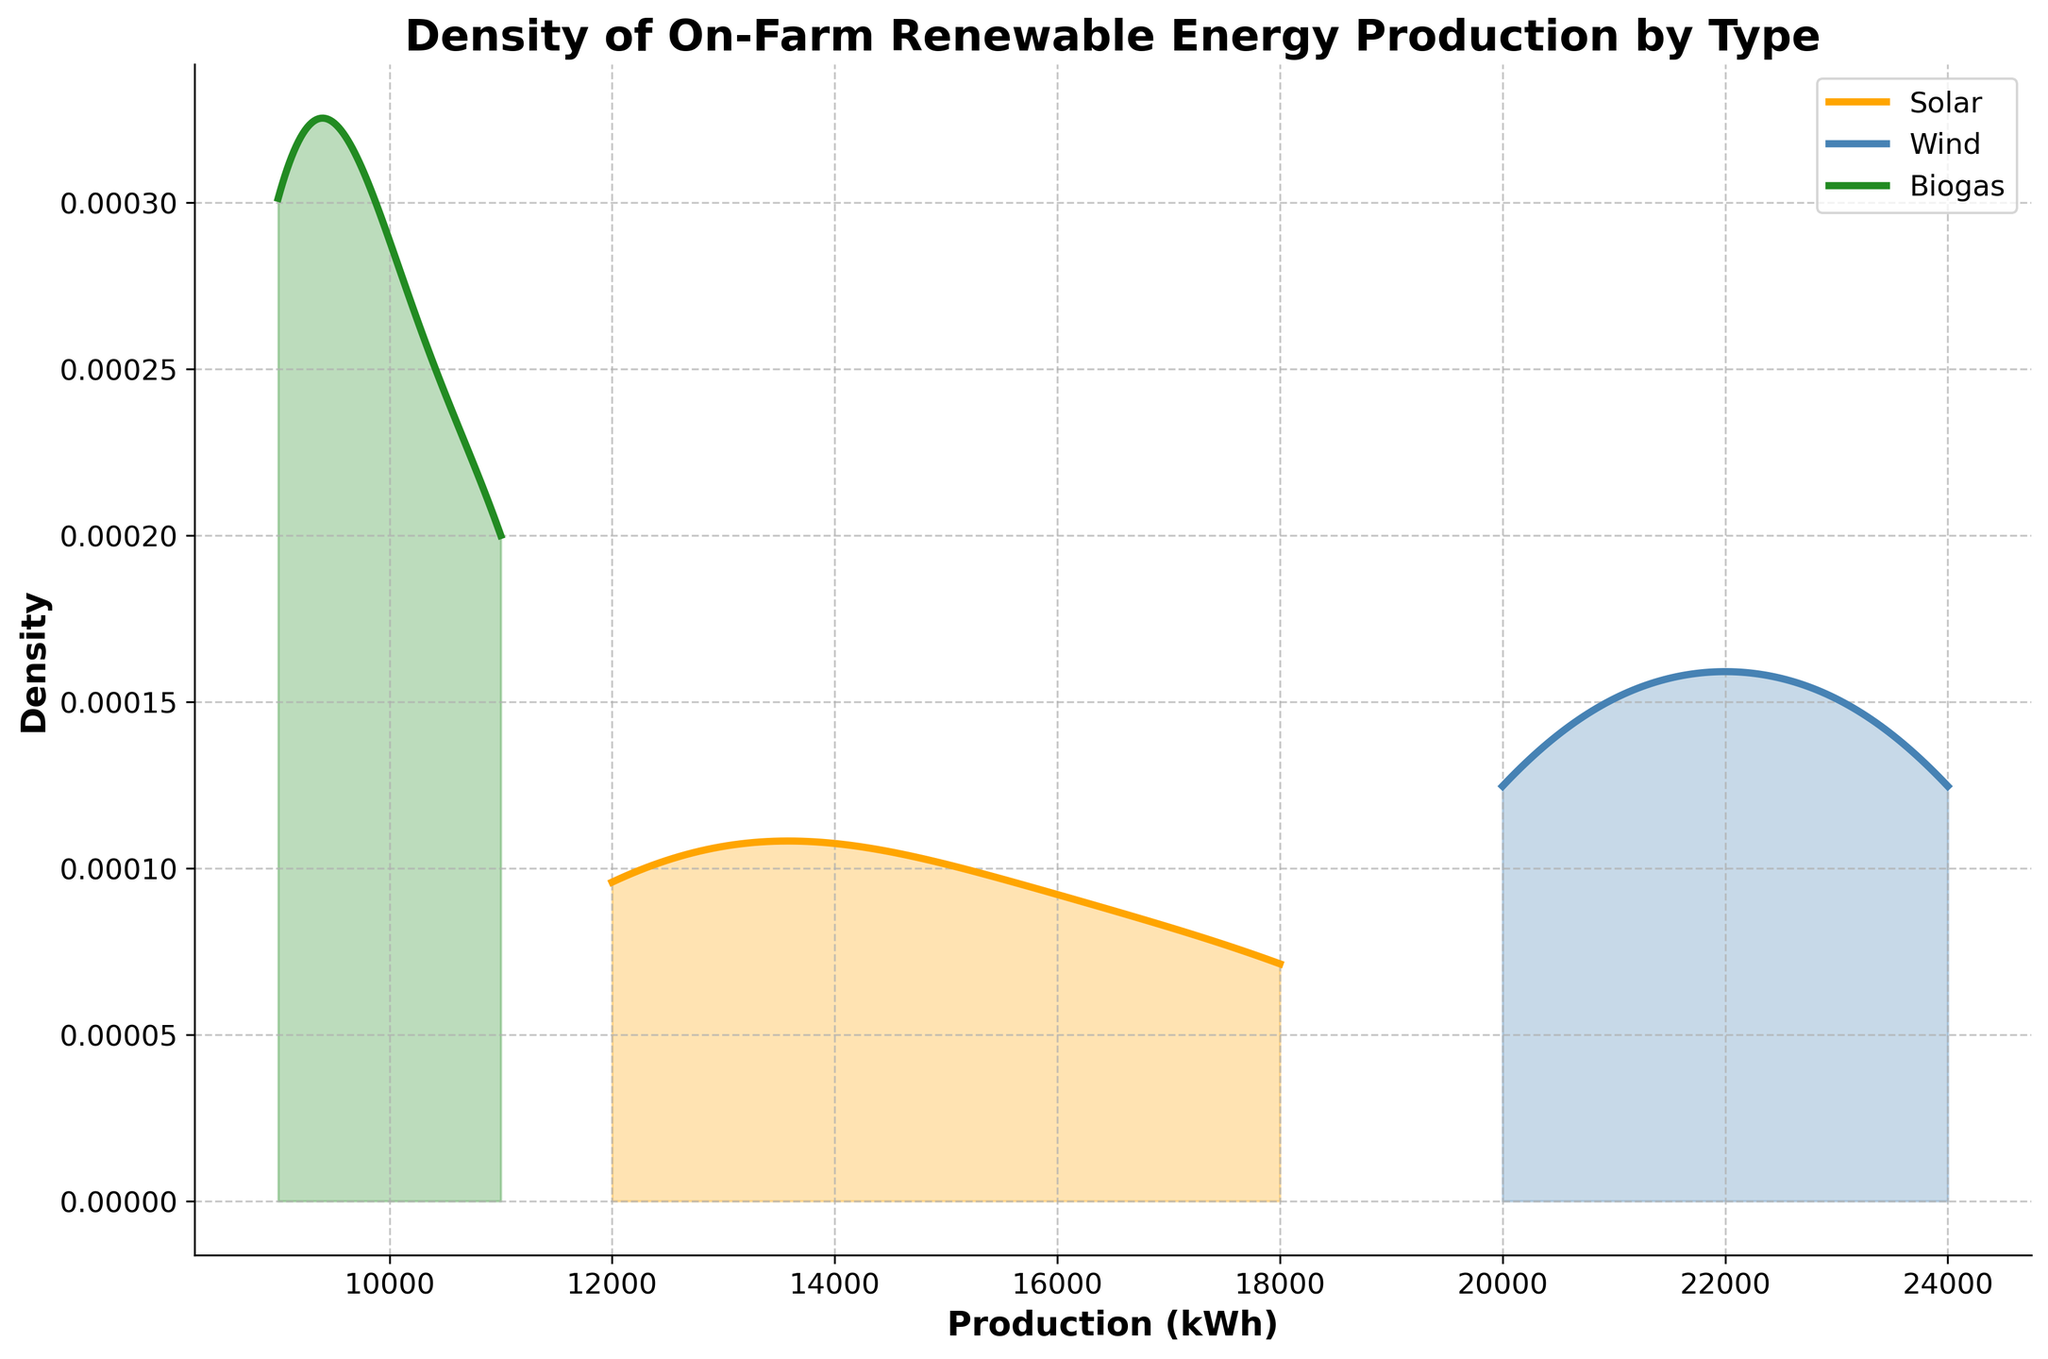what are the renewable energy types shown in the figure? The figure shows the density of production for different types of on-farm renewable energy. By looking at the legend, we can identify the types displayed.
Answer: Solar, Wind, Biogas Which renewable energy type has the highest peak density? The peak density is the highest point of the density curve. By examining each curve's highest point, we can identify which type has the highest peak.
Answer: Wind What is the minimum production value represented in the biogas density curve? The minimum value is the starting point on the x-axis for the biogas density curve. The biogas density curve starts around 9000 kWh.
Answer: 9000 kWh How does the density of solar energy production compare to wind energy production? By comparing the heights and spread of the density curves for solar and wind energy, we can see differences in production distributions. Wind shows a higher peak density, indicating a higher concentration of farms around the mean production than solar.
Answer: Wind has higher density around the mean production than Solar Which type of renewable energy has the widest spread of production values? The spread of values can be determined by the width of the density curve. The wider the spread, the more variation there is in production values. Solar's curve spans a broader range on the x-axis compared to Wind and Biogas.
Answer: Solar What's the approximate production value at the peak density for biogas production? The peak density for biogas production is the highest point on its density curve. By looking at the corresponding x-axis value for this peak, we can approximate it.
Answer: Around 9500 kWh If a farm wants to match the highest density production value in wind energy, how much should it produce? The highest density production value is the peak of the wind density curve. By locating the peak and checking the x-axis, we can find this value.
Answer: Around 22000 kWh What can be inferred about the distribution of biogas production compared to solar? By observing the density curves, biogas has a narrower spread and a lower peak than solar, indicating less variability and a more concentrated production range.
Answer: Biogas has less variability and more concentrated production than solar Between solar and wind energy, which type shows more variability in production values? Variability can be inferred from the spread of the density curves. The wider the curve, the more variability there is. Solar's curve shows a wider spread compared to Wind.
Answer: Solar What is the average production value of solar energy farms if all farms have equal production within the range shown? The average production value is the midpoint of the range of production values for solar energy. The range for solar roughly spans from 12000 to 18000 kWh. The midpoint is calculated as (12000 + 18000) / 2.
Answer: 15000 kWh 